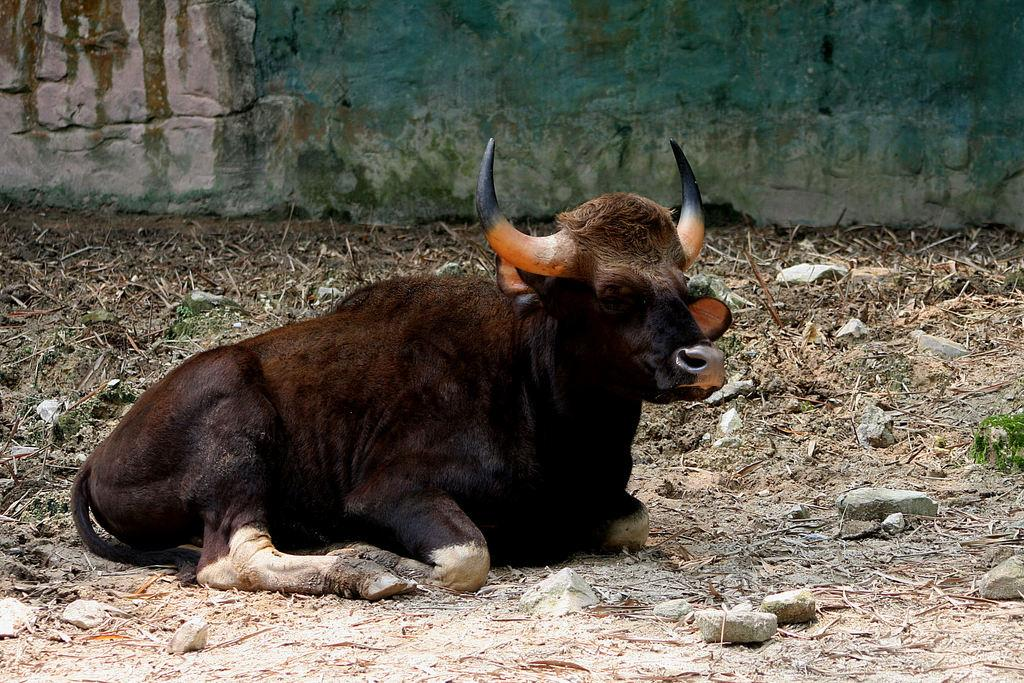What is the main subject in the center of the image? There is a bull in the center of the image. What can be seen on the floor in the image? There are pebbles and dried grass on the floor. What is visible in the background of the image? There is a wall in the background of the image. How does the bull use the fork in the image? There is no fork present in the image, so the bull cannot use one. 